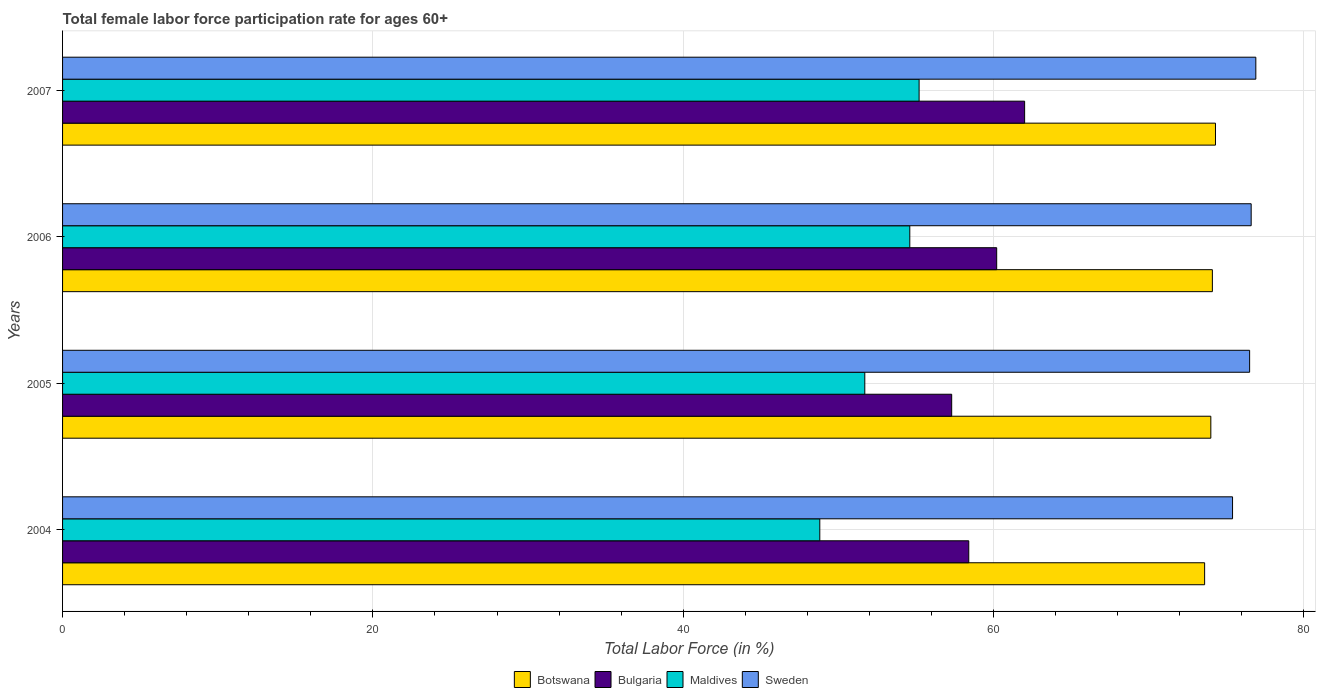Are the number of bars per tick equal to the number of legend labels?
Offer a very short reply. Yes. Are the number of bars on each tick of the Y-axis equal?
Give a very brief answer. Yes. How many bars are there on the 3rd tick from the top?
Ensure brevity in your answer.  4. How many bars are there on the 3rd tick from the bottom?
Your response must be concise. 4. What is the label of the 2nd group of bars from the top?
Your answer should be very brief. 2006. Across all years, what is the maximum female labor force participation rate in Maldives?
Your response must be concise. 55.2. Across all years, what is the minimum female labor force participation rate in Sweden?
Keep it short and to the point. 75.4. In which year was the female labor force participation rate in Maldives maximum?
Your response must be concise. 2007. What is the total female labor force participation rate in Bulgaria in the graph?
Make the answer very short. 237.9. What is the difference between the female labor force participation rate in Bulgaria in 2004 and that in 2007?
Offer a very short reply. -3.6. What is the difference between the female labor force participation rate in Maldives in 2005 and the female labor force participation rate in Bulgaria in 2007?
Ensure brevity in your answer.  -10.3. What is the average female labor force participation rate in Maldives per year?
Provide a succinct answer. 52.57. In how many years, is the female labor force participation rate in Botswana greater than 32 %?
Offer a terse response. 4. What is the ratio of the female labor force participation rate in Botswana in 2004 to that in 2005?
Offer a very short reply. 0.99. What is the difference between the highest and the second highest female labor force participation rate in Maldives?
Offer a very short reply. 0.6. What is the difference between the highest and the lowest female labor force participation rate in Botswana?
Offer a very short reply. 0.7. Is it the case that in every year, the sum of the female labor force participation rate in Sweden and female labor force participation rate in Maldives is greater than the sum of female labor force participation rate in Bulgaria and female labor force participation rate in Botswana?
Offer a terse response. No. What does the 1st bar from the top in 2004 represents?
Make the answer very short. Sweden. What does the 2nd bar from the bottom in 2007 represents?
Your answer should be very brief. Bulgaria. How many bars are there?
Ensure brevity in your answer.  16. Does the graph contain any zero values?
Give a very brief answer. No. Does the graph contain grids?
Make the answer very short. Yes. Where does the legend appear in the graph?
Keep it short and to the point. Bottom center. How are the legend labels stacked?
Your answer should be very brief. Horizontal. What is the title of the graph?
Provide a short and direct response. Total female labor force participation rate for ages 60+. Does "Slovak Republic" appear as one of the legend labels in the graph?
Provide a succinct answer. No. What is the Total Labor Force (in %) in Botswana in 2004?
Keep it short and to the point. 73.6. What is the Total Labor Force (in %) in Bulgaria in 2004?
Make the answer very short. 58.4. What is the Total Labor Force (in %) of Maldives in 2004?
Offer a terse response. 48.8. What is the Total Labor Force (in %) of Sweden in 2004?
Offer a very short reply. 75.4. What is the Total Labor Force (in %) in Botswana in 2005?
Make the answer very short. 74. What is the Total Labor Force (in %) of Bulgaria in 2005?
Ensure brevity in your answer.  57.3. What is the Total Labor Force (in %) of Maldives in 2005?
Give a very brief answer. 51.7. What is the Total Labor Force (in %) in Sweden in 2005?
Your answer should be compact. 76.5. What is the Total Labor Force (in %) in Botswana in 2006?
Offer a terse response. 74.1. What is the Total Labor Force (in %) of Bulgaria in 2006?
Offer a terse response. 60.2. What is the Total Labor Force (in %) in Maldives in 2006?
Offer a terse response. 54.6. What is the Total Labor Force (in %) of Sweden in 2006?
Offer a very short reply. 76.6. What is the Total Labor Force (in %) of Botswana in 2007?
Keep it short and to the point. 74.3. What is the Total Labor Force (in %) in Bulgaria in 2007?
Your response must be concise. 62. What is the Total Labor Force (in %) of Maldives in 2007?
Keep it short and to the point. 55.2. What is the Total Labor Force (in %) of Sweden in 2007?
Provide a succinct answer. 76.9. Across all years, what is the maximum Total Labor Force (in %) of Botswana?
Your response must be concise. 74.3. Across all years, what is the maximum Total Labor Force (in %) in Maldives?
Provide a short and direct response. 55.2. Across all years, what is the maximum Total Labor Force (in %) of Sweden?
Provide a succinct answer. 76.9. Across all years, what is the minimum Total Labor Force (in %) of Botswana?
Keep it short and to the point. 73.6. Across all years, what is the minimum Total Labor Force (in %) of Bulgaria?
Ensure brevity in your answer.  57.3. Across all years, what is the minimum Total Labor Force (in %) of Maldives?
Provide a short and direct response. 48.8. Across all years, what is the minimum Total Labor Force (in %) in Sweden?
Ensure brevity in your answer.  75.4. What is the total Total Labor Force (in %) of Botswana in the graph?
Provide a succinct answer. 296. What is the total Total Labor Force (in %) of Bulgaria in the graph?
Provide a succinct answer. 237.9. What is the total Total Labor Force (in %) of Maldives in the graph?
Provide a short and direct response. 210.3. What is the total Total Labor Force (in %) of Sweden in the graph?
Keep it short and to the point. 305.4. What is the difference between the Total Labor Force (in %) in Botswana in 2004 and that in 2005?
Your answer should be compact. -0.4. What is the difference between the Total Labor Force (in %) of Bulgaria in 2004 and that in 2005?
Offer a terse response. 1.1. What is the difference between the Total Labor Force (in %) of Maldives in 2004 and that in 2005?
Offer a terse response. -2.9. What is the difference between the Total Labor Force (in %) in Bulgaria in 2004 and that in 2006?
Offer a terse response. -1.8. What is the difference between the Total Labor Force (in %) of Sweden in 2004 and that in 2006?
Your response must be concise. -1.2. What is the difference between the Total Labor Force (in %) of Maldives in 2004 and that in 2007?
Ensure brevity in your answer.  -6.4. What is the difference between the Total Labor Force (in %) of Sweden in 2004 and that in 2007?
Make the answer very short. -1.5. What is the difference between the Total Labor Force (in %) in Botswana in 2005 and that in 2006?
Ensure brevity in your answer.  -0.1. What is the difference between the Total Labor Force (in %) in Bulgaria in 2005 and that in 2006?
Your answer should be very brief. -2.9. What is the difference between the Total Labor Force (in %) in Sweden in 2005 and that in 2006?
Offer a very short reply. -0.1. What is the difference between the Total Labor Force (in %) in Sweden in 2005 and that in 2007?
Make the answer very short. -0.4. What is the difference between the Total Labor Force (in %) in Botswana in 2006 and that in 2007?
Make the answer very short. -0.2. What is the difference between the Total Labor Force (in %) of Bulgaria in 2006 and that in 2007?
Offer a terse response. -1.8. What is the difference between the Total Labor Force (in %) in Sweden in 2006 and that in 2007?
Your answer should be compact. -0.3. What is the difference between the Total Labor Force (in %) in Botswana in 2004 and the Total Labor Force (in %) in Maldives in 2005?
Your answer should be compact. 21.9. What is the difference between the Total Labor Force (in %) in Botswana in 2004 and the Total Labor Force (in %) in Sweden in 2005?
Your answer should be very brief. -2.9. What is the difference between the Total Labor Force (in %) of Bulgaria in 2004 and the Total Labor Force (in %) of Sweden in 2005?
Ensure brevity in your answer.  -18.1. What is the difference between the Total Labor Force (in %) in Maldives in 2004 and the Total Labor Force (in %) in Sweden in 2005?
Your response must be concise. -27.7. What is the difference between the Total Labor Force (in %) of Botswana in 2004 and the Total Labor Force (in %) of Sweden in 2006?
Your answer should be very brief. -3. What is the difference between the Total Labor Force (in %) of Bulgaria in 2004 and the Total Labor Force (in %) of Maldives in 2006?
Your response must be concise. 3.8. What is the difference between the Total Labor Force (in %) in Bulgaria in 2004 and the Total Labor Force (in %) in Sweden in 2006?
Give a very brief answer. -18.2. What is the difference between the Total Labor Force (in %) in Maldives in 2004 and the Total Labor Force (in %) in Sweden in 2006?
Give a very brief answer. -27.8. What is the difference between the Total Labor Force (in %) in Botswana in 2004 and the Total Labor Force (in %) in Bulgaria in 2007?
Your answer should be very brief. 11.6. What is the difference between the Total Labor Force (in %) of Botswana in 2004 and the Total Labor Force (in %) of Maldives in 2007?
Your answer should be very brief. 18.4. What is the difference between the Total Labor Force (in %) of Botswana in 2004 and the Total Labor Force (in %) of Sweden in 2007?
Offer a terse response. -3.3. What is the difference between the Total Labor Force (in %) of Bulgaria in 2004 and the Total Labor Force (in %) of Sweden in 2007?
Give a very brief answer. -18.5. What is the difference between the Total Labor Force (in %) in Maldives in 2004 and the Total Labor Force (in %) in Sweden in 2007?
Your response must be concise. -28.1. What is the difference between the Total Labor Force (in %) in Botswana in 2005 and the Total Labor Force (in %) in Sweden in 2006?
Keep it short and to the point. -2.6. What is the difference between the Total Labor Force (in %) of Bulgaria in 2005 and the Total Labor Force (in %) of Sweden in 2006?
Provide a short and direct response. -19.3. What is the difference between the Total Labor Force (in %) in Maldives in 2005 and the Total Labor Force (in %) in Sweden in 2006?
Provide a short and direct response. -24.9. What is the difference between the Total Labor Force (in %) in Botswana in 2005 and the Total Labor Force (in %) in Maldives in 2007?
Your response must be concise. 18.8. What is the difference between the Total Labor Force (in %) of Bulgaria in 2005 and the Total Labor Force (in %) of Sweden in 2007?
Provide a short and direct response. -19.6. What is the difference between the Total Labor Force (in %) of Maldives in 2005 and the Total Labor Force (in %) of Sweden in 2007?
Make the answer very short. -25.2. What is the difference between the Total Labor Force (in %) of Botswana in 2006 and the Total Labor Force (in %) of Bulgaria in 2007?
Your answer should be compact. 12.1. What is the difference between the Total Labor Force (in %) in Botswana in 2006 and the Total Labor Force (in %) in Sweden in 2007?
Offer a terse response. -2.8. What is the difference between the Total Labor Force (in %) of Bulgaria in 2006 and the Total Labor Force (in %) of Sweden in 2007?
Your response must be concise. -16.7. What is the difference between the Total Labor Force (in %) of Maldives in 2006 and the Total Labor Force (in %) of Sweden in 2007?
Provide a short and direct response. -22.3. What is the average Total Labor Force (in %) in Bulgaria per year?
Offer a very short reply. 59.48. What is the average Total Labor Force (in %) of Maldives per year?
Your response must be concise. 52.58. What is the average Total Labor Force (in %) in Sweden per year?
Ensure brevity in your answer.  76.35. In the year 2004, what is the difference between the Total Labor Force (in %) in Botswana and Total Labor Force (in %) in Maldives?
Offer a very short reply. 24.8. In the year 2004, what is the difference between the Total Labor Force (in %) of Maldives and Total Labor Force (in %) of Sweden?
Provide a succinct answer. -26.6. In the year 2005, what is the difference between the Total Labor Force (in %) of Botswana and Total Labor Force (in %) of Maldives?
Ensure brevity in your answer.  22.3. In the year 2005, what is the difference between the Total Labor Force (in %) of Bulgaria and Total Labor Force (in %) of Maldives?
Provide a short and direct response. 5.6. In the year 2005, what is the difference between the Total Labor Force (in %) of Bulgaria and Total Labor Force (in %) of Sweden?
Make the answer very short. -19.2. In the year 2005, what is the difference between the Total Labor Force (in %) of Maldives and Total Labor Force (in %) of Sweden?
Offer a terse response. -24.8. In the year 2006, what is the difference between the Total Labor Force (in %) in Botswana and Total Labor Force (in %) in Maldives?
Give a very brief answer. 19.5. In the year 2006, what is the difference between the Total Labor Force (in %) of Botswana and Total Labor Force (in %) of Sweden?
Provide a succinct answer. -2.5. In the year 2006, what is the difference between the Total Labor Force (in %) in Bulgaria and Total Labor Force (in %) in Sweden?
Make the answer very short. -16.4. In the year 2006, what is the difference between the Total Labor Force (in %) in Maldives and Total Labor Force (in %) in Sweden?
Provide a succinct answer. -22. In the year 2007, what is the difference between the Total Labor Force (in %) of Bulgaria and Total Labor Force (in %) of Maldives?
Your answer should be compact. 6.8. In the year 2007, what is the difference between the Total Labor Force (in %) in Bulgaria and Total Labor Force (in %) in Sweden?
Make the answer very short. -14.9. In the year 2007, what is the difference between the Total Labor Force (in %) of Maldives and Total Labor Force (in %) of Sweden?
Give a very brief answer. -21.7. What is the ratio of the Total Labor Force (in %) in Bulgaria in 2004 to that in 2005?
Make the answer very short. 1.02. What is the ratio of the Total Labor Force (in %) of Maldives in 2004 to that in 2005?
Your answer should be very brief. 0.94. What is the ratio of the Total Labor Force (in %) of Sweden in 2004 to that in 2005?
Offer a terse response. 0.99. What is the ratio of the Total Labor Force (in %) in Botswana in 2004 to that in 2006?
Provide a succinct answer. 0.99. What is the ratio of the Total Labor Force (in %) of Bulgaria in 2004 to that in 2006?
Ensure brevity in your answer.  0.97. What is the ratio of the Total Labor Force (in %) in Maldives in 2004 to that in 2006?
Give a very brief answer. 0.89. What is the ratio of the Total Labor Force (in %) of Sweden in 2004 to that in 2006?
Offer a very short reply. 0.98. What is the ratio of the Total Labor Force (in %) in Botswana in 2004 to that in 2007?
Make the answer very short. 0.99. What is the ratio of the Total Labor Force (in %) in Bulgaria in 2004 to that in 2007?
Keep it short and to the point. 0.94. What is the ratio of the Total Labor Force (in %) in Maldives in 2004 to that in 2007?
Provide a succinct answer. 0.88. What is the ratio of the Total Labor Force (in %) of Sweden in 2004 to that in 2007?
Provide a succinct answer. 0.98. What is the ratio of the Total Labor Force (in %) in Bulgaria in 2005 to that in 2006?
Provide a short and direct response. 0.95. What is the ratio of the Total Labor Force (in %) in Maldives in 2005 to that in 2006?
Make the answer very short. 0.95. What is the ratio of the Total Labor Force (in %) in Sweden in 2005 to that in 2006?
Keep it short and to the point. 1. What is the ratio of the Total Labor Force (in %) of Botswana in 2005 to that in 2007?
Make the answer very short. 1. What is the ratio of the Total Labor Force (in %) in Bulgaria in 2005 to that in 2007?
Your answer should be very brief. 0.92. What is the ratio of the Total Labor Force (in %) in Maldives in 2005 to that in 2007?
Make the answer very short. 0.94. What is the ratio of the Total Labor Force (in %) of Sweden in 2005 to that in 2007?
Provide a short and direct response. 0.99. What is the ratio of the Total Labor Force (in %) of Botswana in 2006 to that in 2007?
Keep it short and to the point. 1. What is the ratio of the Total Labor Force (in %) in Bulgaria in 2006 to that in 2007?
Give a very brief answer. 0.97. What is the difference between the highest and the second highest Total Labor Force (in %) in Botswana?
Ensure brevity in your answer.  0.2. What is the difference between the highest and the second highest Total Labor Force (in %) of Maldives?
Offer a terse response. 0.6. 